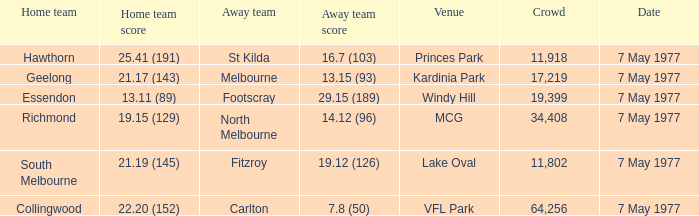Name the venue with a home team of geelong Kardinia Park. 